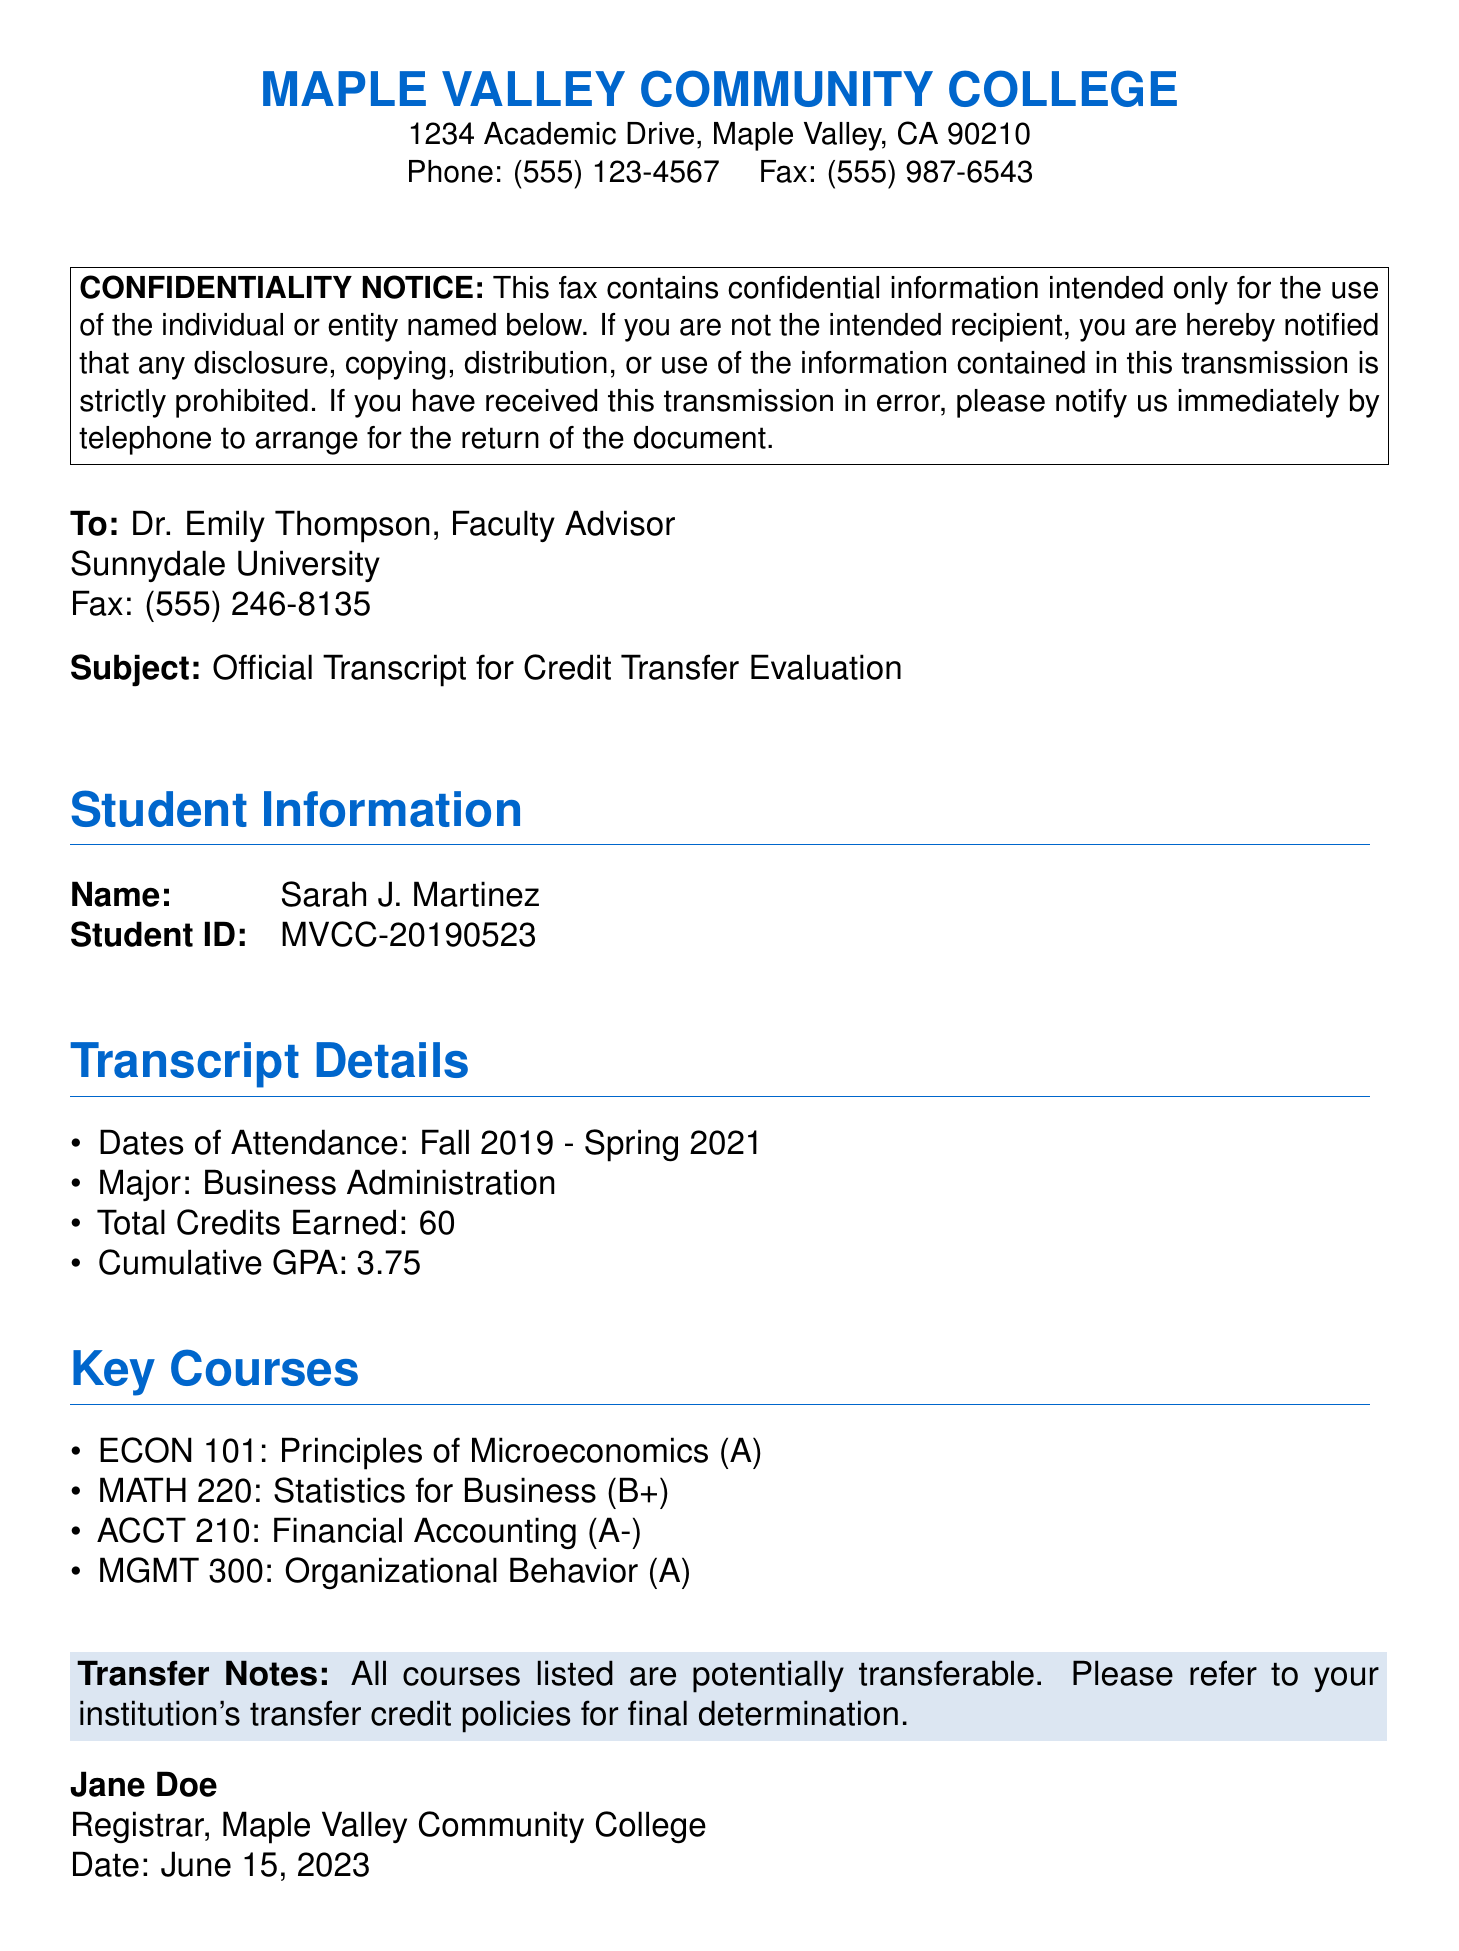What is the name of the student? The document lists the student's name in the "Student Information" section as Sarah J. Martinez.
Answer: Sarah J. Martinez What is the student's cumulative GPA? The cumulative GPA is specified in the "Transcript Details" section of the document.
Answer: 3.75 What are the dates of attendance? The document states the dates of attendance under the "Transcript Details" section.
Answer: Fall 2019 - Spring 2021 How many total credits did the student earn? The total credits earned are mentioned in the "Transcript Details" section.
Answer: 60 What major did the student pursue? The major is listed in the "Transcript Details" section.
Answer: Business Administration Which course received a grade of A-? The grades for the courses are listed in the "Key Courses" section; ACCT 210 received an A-.
Answer: ACCT 210 What is the subject of the fax? The subject line explicitly states the purpose of the fax.
Answer: Official Transcript for Credit Transfer Evaluation Who is sending the fax? The sender's name is provided at the end of the document.
Answer: Jane Doe What institution is the fax being sent to? The recipient's institution is listed in the "To" section of the document.
Answer: Sunnydale University What is the contact fax number for the recipient? The fax number for the recipient is included in the "To" section.
Answer: (555) 246-8135 